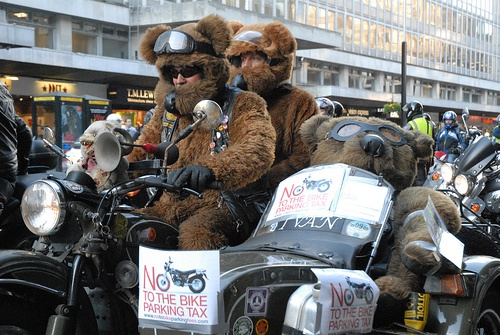Describe the objects in this image and their specific colors. I can see motorcycle in lightblue, white, black, gray, and darkgray tones, motorcycle in lightblue, black, gray, darkgray, and white tones, people in lightblue, black, maroon, and gray tones, people in lightblue, black, maroon, and gray tones, and teddy bear in lightblue, gray, black, and darkgray tones in this image. 